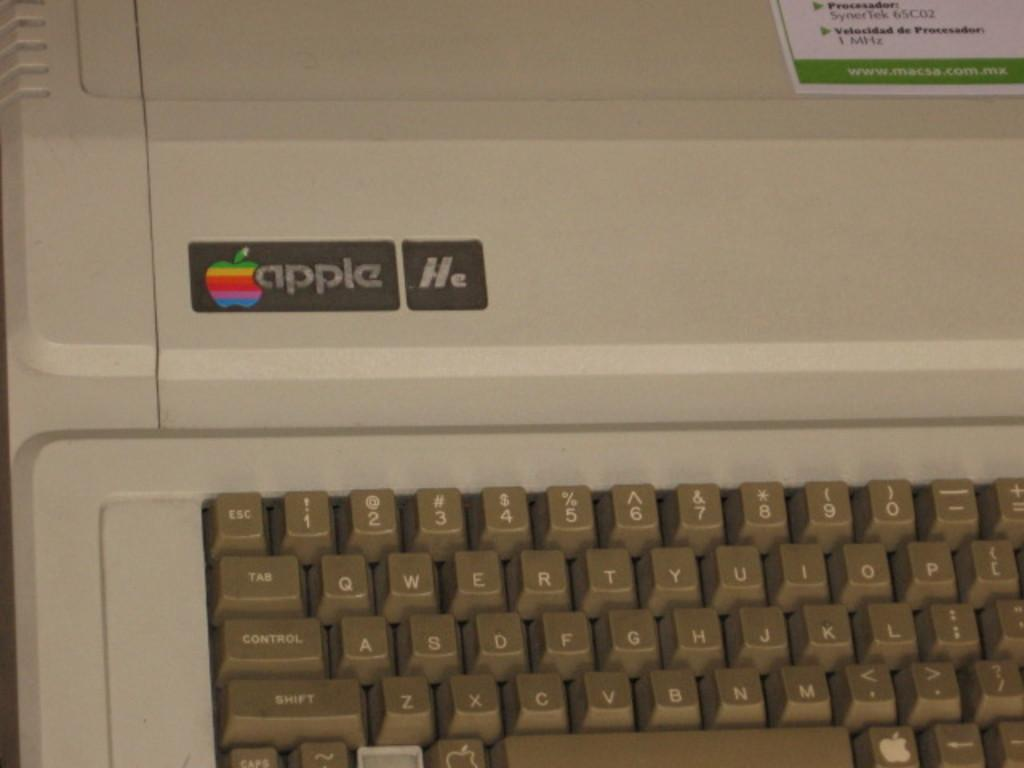<image>
Give a short and clear explanation of the subsequent image. An old Apple computer that is very out of date and of no use any longer. 